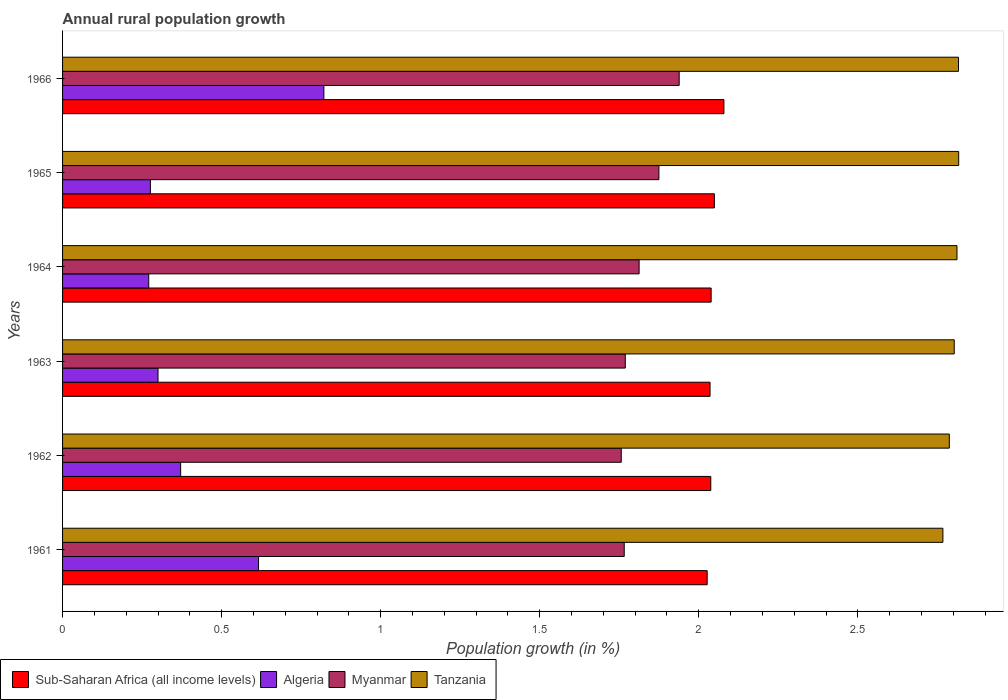How many groups of bars are there?
Your answer should be very brief. 6. How many bars are there on the 1st tick from the top?
Offer a very short reply. 4. What is the label of the 4th group of bars from the top?
Provide a succinct answer. 1963. What is the percentage of rural population growth in Myanmar in 1961?
Your answer should be compact. 1.77. Across all years, what is the maximum percentage of rural population growth in Tanzania?
Give a very brief answer. 2.82. Across all years, what is the minimum percentage of rural population growth in Sub-Saharan Africa (all income levels)?
Your answer should be compact. 2.03. In which year was the percentage of rural population growth in Myanmar maximum?
Your answer should be compact. 1966. What is the total percentage of rural population growth in Tanzania in the graph?
Your answer should be compact. 16.8. What is the difference between the percentage of rural population growth in Sub-Saharan Africa (all income levels) in 1961 and that in 1964?
Make the answer very short. -0.01. What is the difference between the percentage of rural population growth in Sub-Saharan Africa (all income levels) in 1962 and the percentage of rural population growth in Myanmar in 1963?
Your response must be concise. 0.27. What is the average percentage of rural population growth in Sub-Saharan Africa (all income levels) per year?
Offer a terse response. 2.04. In the year 1965, what is the difference between the percentage of rural population growth in Sub-Saharan Africa (all income levels) and percentage of rural population growth in Algeria?
Provide a short and direct response. 1.77. In how many years, is the percentage of rural population growth in Sub-Saharan Africa (all income levels) greater than 0.5 %?
Give a very brief answer. 6. What is the ratio of the percentage of rural population growth in Tanzania in 1962 to that in 1966?
Your answer should be compact. 0.99. Is the percentage of rural population growth in Algeria in 1963 less than that in 1964?
Ensure brevity in your answer.  No. Is the difference between the percentage of rural population growth in Sub-Saharan Africa (all income levels) in 1962 and 1964 greater than the difference between the percentage of rural population growth in Algeria in 1962 and 1964?
Your answer should be very brief. No. What is the difference between the highest and the second highest percentage of rural population growth in Sub-Saharan Africa (all income levels)?
Your response must be concise. 0.03. What is the difference between the highest and the lowest percentage of rural population growth in Sub-Saharan Africa (all income levels)?
Your response must be concise. 0.05. In how many years, is the percentage of rural population growth in Algeria greater than the average percentage of rural population growth in Algeria taken over all years?
Your answer should be compact. 2. Is the sum of the percentage of rural population growth in Myanmar in 1962 and 1966 greater than the maximum percentage of rural population growth in Tanzania across all years?
Provide a short and direct response. Yes. Is it the case that in every year, the sum of the percentage of rural population growth in Myanmar and percentage of rural population growth in Tanzania is greater than the sum of percentage of rural population growth in Sub-Saharan Africa (all income levels) and percentage of rural population growth in Algeria?
Give a very brief answer. Yes. What does the 2nd bar from the top in 1964 represents?
Keep it short and to the point. Myanmar. What does the 3rd bar from the bottom in 1964 represents?
Offer a terse response. Myanmar. How many bars are there?
Ensure brevity in your answer.  24. What is the difference between two consecutive major ticks on the X-axis?
Your answer should be very brief. 0.5. Are the values on the major ticks of X-axis written in scientific E-notation?
Your answer should be compact. No. Where does the legend appear in the graph?
Give a very brief answer. Bottom left. How are the legend labels stacked?
Offer a terse response. Horizontal. What is the title of the graph?
Provide a succinct answer. Annual rural population growth. Does "Aruba" appear as one of the legend labels in the graph?
Your answer should be compact. No. What is the label or title of the X-axis?
Your response must be concise. Population growth (in %). What is the Population growth (in %) in Sub-Saharan Africa (all income levels) in 1961?
Offer a terse response. 2.03. What is the Population growth (in %) in Algeria in 1961?
Give a very brief answer. 0.62. What is the Population growth (in %) of Myanmar in 1961?
Keep it short and to the point. 1.77. What is the Population growth (in %) of Tanzania in 1961?
Offer a terse response. 2.77. What is the Population growth (in %) in Sub-Saharan Africa (all income levels) in 1962?
Ensure brevity in your answer.  2.04. What is the Population growth (in %) in Algeria in 1962?
Your answer should be very brief. 0.37. What is the Population growth (in %) of Myanmar in 1962?
Your answer should be compact. 1.76. What is the Population growth (in %) of Tanzania in 1962?
Make the answer very short. 2.79. What is the Population growth (in %) of Sub-Saharan Africa (all income levels) in 1963?
Your answer should be compact. 2.04. What is the Population growth (in %) in Algeria in 1963?
Provide a short and direct response. 0.3. What is the Population growth (in %) of Myanmar in 1963?
Provide a succinct answer. 1.77. What is the Population growth (in %) of Tanzania in 1963?
Offer a very short reply. 2.8. What is the Population growth (in %) in Sub-Saharan Africa (all income levels) in 1964?
Give a very brief answer. 2.04. What is the Population growth (in %) in Algeria in 1964?
Your answer should be very brief. 0.27. What is the Population growth (in %) in Myanmar in 1964?
Ensure brevity in your answer.  1.81. What is the Population growth (in %) of Tanzania in 1964?
Your answer should be compact. 2.81. What is the Population growth (in %) of Sub-Saharan Africa (all income levels) in 1965?
Your answer should be very brief. 2.05. What is the Population growth (in %) in Algeria in 1965?
Provide a short and direct response. 0.28. What is the Population growth (in %) of Myanmar in 1965?
Offer a terse response. 1.87. What is the Population growth (in %) in Tanzania in 1965?
Provide a short and direct response. 2.82. What is the Population growth (in %) in Sub-Saharan Africa (all income levels) in 1966?
Ensure brevity in your answer.  2.08. What is the Population growth (in %) of Algeria in 1966?
Your answer should be compact. 0.82. What is the Population growth (in %) of Myanmar in 1966?
Offer a terse response. 1.94. What is the Population growth (in %) in Tanzania in 1966?
Your answer should be compact. 2.82. Across all years, what is the maximum Population growth (in %) in Sub-Saharan Africa (all income levels)?
Your answer should be very brief. 2.08. Across all years, what is the maximum Population growth (in %) of Algeria?
Your answer should be very brief. 0.82. Across all years, what is the maximum Population growth (in %) of Myanmar?
Your answer should be compact. 1.94. Across all years, what is the maximum Population growth (in %) in Tanzania?
Provide a succinct answer. 2.82. Across all years, what is the minimum Population growth (in %) in Sub-Saharan Africa (all income levels)?
Your answer should be compact. 2.03. Across all years, what is the minimum Population growth (in %) of Algeria?
Ensure brevity in your answer.  0.27. Across all years, what is the minimum Population growth (in %) of Myanmar?
Ensure brevity in your answer.  1.76. Across all years, what is the minimum Population growth (in %) in Tanzania?
Provide a short and direct response. 2.77. What is the total Population growth (in %) of Sub-Saharan Africa (all income levels) in the graph?
Ensure brevity in your answer.  12.27. What is the total Population growth (in %) in Algeria in the graph?
Make the answer very short. 2.66. What is the total Population growth (in %) of Myanmar in the graph?
Keep it short and to the point. 10.92. What is the total Population growth (in %) of Tanzania in the graph?
Provide a succinct answer. 16.8. What is the difference between the Population growth (in %) of Sub-Saharan Africa (all income levels) in 1961 and that in 1962?
Ensure brevity in your answer.  -0.01. What is the difference between the Population growth (in %) in Algeria in 1961 and that in 1962?
Ensure brevity in your answer.  0.24. What is the difference between the Population growth (in %) of Myanmar in 1961 and that in 1962?
Offer a very short reply. 0.01. What is the difference between the Population growth (in %) in Tanzania in 1961 and that in 1962?
Your answer should be very brief. -0.02. What is the difference between the Population growth (in %) in Sub-Saharan Africa (all income levels) in 1961 and that in 1963?
Your response must be concise. -0.01. What is the difference between the Population growth (in %) of Algeria in 1961 and that in 1963?
Provide a succinct answer. 0.32. What is the difference between the Population growth (in %) of Myanmar in 1961 and that in 1963?
Make the answer very short. -0. What is the difference between the Population growth (in %) of Tanzania in 1961 and that in 1963?
Your answer should be compact. -0.04. What is the difference between the Population growth (in %) of Sub-Saharan Africa (all income levels) in 1961 and that in 1964?
Keep it short and to the point. -0.01. What is the difference between the Population growth (in %) in Algeria in 1961 and that in 1964?
Offer a terse response. 0.35. What is the difference between the Population growth (in %) in Myanmar in 1961 and that in 1964?
Ensure brevity in your answer.  -0.05. What is the difference between the Population growth (in %) in Tanzania in 1961 and that in 1964?
Your response must be concise. -0.04. What is the difference between the Population growth (in %) of Sub-Saharan Africa (all income levels) in 1961 and that in 1965?
Ensure brevity in your answer.  -0.02. What is the difference between the Population growth (in %) of Algeria in 1961 and that in 1965?
Give a very brief answer. 0.34. What is the difference between the Population growth (in %) of Myanmar in 1961 and that in 1965?
Offer a terse response. -0.11. What is the difference between the Population growth (in %) of Tanzania in 1961 and that in 1965?
Your response must be concise. -0.05. What is the difference between the Population growth (in %) in Sub-Saharan Africa (all income levels) in 1961 and that in 1966?
Offer a very short reply. -0.05. What is the difference between the Population growth (in %) of Algeria in 1961 and that in 1966?
Your answer should be very brief. -0.21. What is the difference between the Population growth (in %) in Myanmar in 1961 and that in 1966?
Ensure brevity in your answer.  -0.17. What is the difference between the Population growth (in %) in Tanzania in 1961 and that in 1966?
Your answer should be compact. -0.05. What is the difference between the Population growth (in %) of Sub-Saharan Africa (all income levels) in 1962 and that in 1963?
Your answer should be compact. 0. What is the difference between the Population growth (in %) of Algeria in 1962 and that in 1963?
Make the answer very short. 0.07. What is the difference between the Population growth (in %) of Myanmar in 1962 and that in 1963?
Your answer should be very brief. -0.01. What is the difference between the Population growth (in %) of Tanzania in 1962 and that in 1963?
Make the answer very short. -0.02. What is the difference between the Population growth (in %) of Sub-Saharan Africa (all income levels) in 1962 and that in 1964?
Keep it short and to the point. -0. What is the difference between the Population growth (in %) of Algeria in 1962 and that in 1964?
Provide a succinct answer. 0.1. What is the difference between the Population growth (in %) in Myanmar in 1962 and that in 1964?
Keep it short and to the point. -0.06. What is the difference between the Population growth (in %) of Tanzania in 1962 and that in 1964?
Provide a succinct answer. -0.02. What is the difference between the Population growth (in %) in Sub-Saharan Africa (all income levels) in 1962 and that in 1965?
Your response must be concise. -0.01. What is the difference between the Population growth (in %) of Algeria in 1962 and that in 1965?
Provide a short and direct response. 0.1. What is the difference between the Population growth (in %) of Myanmar in 1962 and that in 1965?
Provide a short and direct response. -0.12. What is the difference between the Population growth (in %) in Tanzania in 1962 and that in 1965?
Provide a short and direct response. -0.03. What is the difference between the Population growth (in %) in Sub-Saharan Africa (all income levels) in 1962 and that in 1966?
Your answer should be very brief. -0.04. What is the difference between the Population growth (in %) in Algeria in 1962 and that in 1966?
Your response must be concise. -0.45. What is the difference between the Population growth (in %) of Myanmar in 1962 and that in 1966?
Provide a short and direct response. -0.18. What is the difference between the Population growth (in %) in Tanzania in 1962 and that in 1966?
Make the answer very short. -0.03. What is the difference between the Population growth (in %) of Sub-Saharan Africa (all income levels) in 1963 and that in 1964?
Make the answer very short. -0. What is the difference between the Population growth (in %) of Algeria in 1963 and that in 1964?
Your response must be concise. 0.03. What is the difference between the Population growth (in %) of Myanmar in 1963 and that in 1964?
Offer a terse response. -0.04. What is the difference between the Population growth (in %) in Tanzania in 1963 and that in 1964?
Keep it short and to the point. -0.01. What is the difference between the Population growth (in %) in Sub-Saharan Africa (all income levels) in 1963 and that in 1965?
Make the answer very short. -0.01. What is the difference between the Population growth (in %) of Algeria in 1963 and that in 1965?
Your answer should be very brief. 0.02. What is the difference between the Population growth (in %) of Myanmar in 1963 and that in 1965?
Your answer should be compact. -0.11. What is the difference between the Population growth (in %) in Tanzania in 1963 and that in 1965?
Make the answer very short. -0.01. What is the difference between the Population growth (in %) of Sub-Saharan Africa (all income levels) in 1963 and that in 1966?
Offer a terse response. -0.04. What is the difference between the Population growth (in %) of Algeria in 1963 and that in 1966?
Your answer should be very brief. -0.52. What is the difference between the Population growth (in %) of Myanmar in 1963 and that in 1966?
Offer a very short reply. -0.17. What is the difference between the Population growth (in %) in Tanzania in 1963 and that in 1966?
Give a very brief answer. -0.01. What is the difference between the Population growth (in %) of Sub-Saharan Africa (all income levels) in 1964 and that in 1965?
Your response must be concise. -0.01. What is the difference between the Population growth (in %) of Algeria in 1964 and that in 1965?
Provide a short and direct response. -0.01. What is the difference between the Population growth (in %) in Myanmar in 1964 and that in 1965?
Your answer should be compact. -0.06. What is the difference between the Population growth (in %) of Tanzania in 1964 and that in 1965?
Keep it short and to the point. -0.01. What is the difference between the Population growth (in %) in Sub-Saharan Africa (all income levels) in 1964 and that in 1966?
Your answer should be very brief. -0.04. What is the difference between the Population growth (in %) of Algeria in 1964 and that in 1966?
Provide a short and direct response. -0.55. What is the difference between the Population growth (in %) in Myanmar in 1964 and that in 1966?
Offer a terse response. -0.13. What is the difference between the Population growth (in %) of Tanzania in 1964 and that in 1966?
Provide a succinct answer. -0. What is the difference between the Population growth (in %) of Sub-Saharan Africa (all income levels) in 1965 and that in 1966?
Keep it short and to the point. -0.03. What is the difference between the Population growth (in %) of Algeria in 1965 and that in 1966?
Offer a terse response. -0.55. What is the difference between the Population growth (in %) of Myanmar in 1965 and that in 1966?
Make the answer very short. -0.06. What is the difference between the Population growth (in %) of Tanzania in 1965 and that in 1966?
Offer a terse response. 0. What is the difference between the Population growth (in %) of Sub-Saharan Africa (all income levels) in 1961 and the Population growth (in %) of Algeria in 1962?
Make the answer very short. 1.66. What is the difference between the Population growth (in %) of Sub-Saharan Africa (all income levels) in 1961 and the Population growth (in %) of Myanmar in 1962?
Give a very brief answer. 0.27. What is the difference between the Population growth (in %) of Sub-Saharan Africa (all income levels) in 1961 and the Population growth (in %) of Tanzania in 1962?
Provide a short and direct response. -0.76. What is the difference between the Population growth (in %) of Algeria in 1961 and the Population growth (in %) of Myanmar in 1962?
Provide a short and direct response. -1.14. What is the difference between the Population growth (in %) in Algeria in 1961 and the Population growth (in %) in Tanzania in 1962?
Offer a terse response. -2.17. What is the difference between the Population growth (in %) of Myanmar in 1961 and the Population growth (in %) of Tanzania in 1962?
Make the answer very short. -1.02. What is the difference between the Population growth (in %) of Sub-Saharan Africa (all income levels) in 1961 and the Population growth (in %) of Algeria in 1963?
Make the answer very short. 1.73. What is the difference between the Population growth (in %) in Sub-Saharan Africa (all income levels) in 1961 and the Population growth (in %) in Myanmar in 1963?
Your answer should be very brief. 0.26. What is the difference between the Population growth (in %) of Sub-Saharan Africa (all income levels) in 1961 and the Population growth (in %) of Tanzania in 1963?
Provide a succinct answer. -0.78. What is the difference between the Population growth (in %) of Algeria in 1961 and the Population growth (in %) of Myanmar in 1963?
Offer a very short reply. -1.15. What is the difference between the Population growth (in %) in Algeria in 1961 and the Population growth (in %) in Tanzania in 1963?
Your answer should be compact. -2.19. What is the difference between the Population growth (in %) in Myanmar in 1961 and the Population growth (in %) in Tanzania in 1963?
Make the answer very short. -1.04. What is the difference between the Population growth (in %) of Sub-Saharan Africa (all income levels) in 1961 and the Population growth (in %) of Algeria in 1964?
Give a very brief answer. 1.76. What is the difference between the Population growth (in %) in Sub-Saharan Africa (all income levels) in 1961 and the Population growth (in %) in Myanmar in 1964?
Your answer should be compact. 0.21. What is the difference between the Population growth (in %) of Sub-Saharan Africa (all income levels) in 1961 and the Population growth (in %) of Tanzania in 1964?
Give a very brief answer. -0.79. What is the difference between the Population growth (in %) in Algeria in 1961 and the Population growth (in %) in Myanmar in 1964?
Keep it short and to the point. -1.2. What is the difference between the Population growth (in %) of Algeria in 1961 and the Population growth (in %) of Tanzania in 1964?
Your answer should be compact. -2.2. What is the difference between the Population growth (in %) of Myanmar in 1961 and the Population growth (in %) of Tanzania in 1964?
Your answer should be compact. -1.05. What is the difference between the Population growth (in %) in Sub-Saharan Africa (all income levels) in 1961 and the Population growth (in %) in Algeria in 1965?
Offer a very short reply. 1.75. What is the difference between the Population growth (in %) of Sub-Saharan Africa (all income levels) in 1961 and the Population growth (in %) of Myanmar in 1965?
Provide a succinct answer. 0.15. What is the difference between the Population growth (in %) in Sub-Saharan Africa (all income levels) in 1961 and the Population growth (in %) in Tanzania in 1965?
Keep it short and to the point. -0.79. What is the difference between the Population growth (in %) of Algeria in 1961 and the Population growth (in %) of Myanmar in 1965?
Ensure brevity in your answer.  -1.26. What is the difference between the Population growth (in %) of Algeria in 1961 and the Population growth (in %) of Tanzania in 1965?
Offer a very short reply. -2.2. What is the difference between the Population growth (in %) in Myanmar in 1961 and the Population growth (in %) in Tanzania in 1965?
Make the answer very short. -1.05. What is the difference between the Population growth (in %) in Sub-Saharan Africa (all income levels) in 1961 and the Population growth (in %) in Algeria in 1966?
Keep it short and to the point. 1.2. What is the difference between the Population growth (in %) in Sub-Saharan Africa (all income levels) in 1961 and the Population growth (in %) in Myanmar in 1966?
Make the answer very short. 0.09. What is the difference between the Population growth (in %) in Sub-Saharan Africa (all income levels) in 1961 and the Population growth (in %) in Tanzania in 1966?
Ensure brevity in your answer.  -0.79. What is the difference between the Population growth (in %) in Algeria in 1961 and the Population growth (in %) in Myanmar in 1966?
Keep it short and to the point. -1.32. What is the difference between the Population growth (in %) in Algeria in 1961 and the Population growth (in %) in Tanzania in 1966?
Offer a terse response. -2.2. What is the difference between the Population growth (in %) in Myanmar in 1961 and the Population growth (in %) in Tanzania in 1966?
Offer a very short reply. -1.05. What is the difference between the Population growth (in %) in Sub-Saharan Africa (all income levels) in 1962 and the Population growth (in %) in Algeria in 1963?
Your answer should be very brief. 1.74. What is the difference between the Population growth (in %) of Sub-Saharan Africa (all income levels) in 1962 and the Population growth (in %) of Myanmar in 1963?
Ensure brevity in your answer.  0.27. What is the difference between the Population growth (in %) of Sub-Saharan Africa (all income levels) in 1962 and the Population growth (in %) of Tanzania in 1963?
Provide a short and direct response. -0.77. What is the difference between the Population growth (in %) of Algeria in 1962 and the Population growth (in %) of Myanmar in 1963?
Keep it short and to the point. -1.4. What is the difference between the Population growth (in %) in Algeria in 1962 and the Population growth (in %) in Tanzania in 1963?
Provide a short and direct response. -2.43. What is the difference between the Population growth (in %) in Myanmar in 1962 and the Population growth (in %) in Tanzania in 1963?
Your answer should be very brief. -1.05. What is the difference between the Population growth (in %) in Sub-Saharan Africa (all income levels) in 1962 and the Population growth (in %) in Algeria in 1964?
Your response must be concise. 1.77. What is the difference between the Population growth (in %) in Sub-Saharan Africa (all income levels) in 1962 and the Population growth (in %) in Myanmar in 1964?
Keep it short and to the point. 0.23. What is the difference between the Population growth (in %) in Sub-Saharan Africa (all income levels) in 1962 and the Population growth (in %) in Tanzania in 1964?
Keep it short and to the point. -0.77. What is the difference between the Population growth (in %) in Algeria in 1962 and the Population growth (in %) in Myanmar in 1964?
Your answer should be compact. -1.44. What is the difference between the Population growth (in %) in Algeria in 1962 and the Population growth (in %) in Tanzania in 1964?
Offer a terse response. -2.44. What is the difference between the Population growth (in %) in Myanmar in 1962 and the Population growth (in %) in Tanzania in 1964?
Your answer should be compact. -1.06. What is the difference between the Population growth (in %) in Sub-Saharan Africa (all income levels) in 1962 and the Population growth (in %) in Algeria in 1965?
Your answer should be very brief. 1.76. What is the difference between the Population growth (in %) of Sub-Saharan Africa (all income levels) in 1962 and the Population growth (in %) of Myanmar in 1965?
Provide a succinct answer. 0.16. What is the difference between the Population growth (in %) of Sub-Saharan Africa (all income levels) in 1962 and the Population growth (in %) of Tanzania in 1965?
Your answer should be compact. -0.78. What is the difference between the Population growth (in %) of Algeria in 1962 and the Population growth (in %) of Myanmar in 1965?
Make the answer very short. -1.5. What is the difference between the Population growth (in %) of Algeria in 1962 and the Population growth (in %) of Tanzania in 1965?
Your answer should be compact. -2.45. What is the difference between the Population growth (in %) in Myanmar in 1962 and the Population growth (in %) in Tanzania in 1965?
Ensure brevity in your answer.  -1.06. What is the difference between the Population growth (in %) of Sub-Saharan Africa (all income levels) in 1962 and the Population growth (in %) of Algeria in 1966?
Provide a succinct answer. 1.22. What is the difference between the Population growth (in %) of Sub-Saharan Africa (all income levels) in 1962 and the Population growth (in %) of Myanmar in 1966?
Your answer should be very brief. 0.1. What is the difference between the Population growth (in %) in Sub-Saharan Africa (all income levels) in 1962 and the Population growth (in %) in Tanzania in 1966?
Ensure brevity in your answer.  -0.78. What is the difference between the Population growth (in %) of Algeria in 1962 and the Population growth (in %) of Myanmar in 1966?
Give a very brief answer. -1.57. What is the difference between the Population growth (in %) in Algeria in 1962 and the Population growth (in %) in Tanzania in 1966?
Give a very brief answer. -2.45. What is the difference between the Population growth (in %) in Myanmar in 1962 and the Population growth (in %) in Tanzania in 1966?
Your answer should be very brief. -1.06. What is the difference between the Population growth (in %) in Sub-Saharan Africa (all income levels) in 1963 and the Population growth (in %) in Algeria in 1964?
Your response must be concise. 1.76. What is the difference between the Population growth (in %) in Sub-Saharan Africa (all income levels) in 1963 and the Population growth (in %) in Myanmar in 1964?
Provide a short and direct response. 0.22. What is the difference between the Population growth (in %) of Sub-Saharan Africa (all income levels) in 1963 and the Population growth (in %) of Tanzania in 1964?
Your answer should be compact. -0.78. What is the difference between the Population growth (in %) of Algeria in 1963 and the Population growth (in %) of Myanmar in 1964?
Give a very brief answer. -1.51. What is the difference between the Population growth (in %) of Algeria in 1963 and the Population growth (in %) of Tanzania in 1964?
Provide a succinct answer. -2.51. What is the difference between the Population growth (in %) of Myanmar in 1963 and the Population growth (in %) of Tanzania in 1964?
Keep it short and to the point. -1.04. What is the difference between the Population growth (in %) in Sub-Saharan Africa (all income levels) in 1963 and the Population growth (in %) in Algeria in 1965?
Provide a succinct answer. 1.76. What is the difference between the Population growth (in %) of Sub-Saharan Africa (all income levels) in 1963 and the Population growth (in %) of Myanmar in 1965?
Keep it short and to the point. 0.16. What is the difference between the Population growth (in %) in Sub-Saharan Africa (all income levels) in 1963 and the Population growth (in %) in Tanzania in 1965?
Keep it short and to the point. -0.78. What is the difference between the Population growth (in %) in Algeria in 1963 and the Population growth (in %) in Myanmar in 1965?
Make the answer very short. -1.57. What is the difference between the Population growth (in %) in Algeria in 1963 and the Population growth (in %) in Tanzania in 1965?
Offer a very short reply. -2.52. What is the difference between the Population growth (in %) in Myanmar in 1963 and the Population growth (in %) in Tanzania in 1965?
Provide a short and direct response. -1.05. What is the difference between the Population growth (in %) of Sub-Saharan Africa (all income levels) in 1963 and the Population growth (in %) of Algeria in 1966?
Offer a terse response. 1.21. What is the difference between the Population growth (in %) in Sub-Saharan Africa (all income levels) in 1963 and the Population growth (in %) in Myanmar in 1966?
Your response must be concise. 0.1. What is the difference between the Population growth (in %) in Sub-Saharan Africa (all income levels) in 1963 and the Population growth (in %) in Tanzania in 1966?
Your answer should be compact. -0.78. What is the difference between the Population growth (in %) of Algeria in 1963 and the Population growth (in %) of Myanmar in 1966?
Your answer should be very brief. -1.64. What is the difference between the Population growth (in %) in Algeria in 1963 and the Population growth (in %) in Tanzania in 1966?
Provide a short and direct response. -2.52. What is the difference between the Population growth (in %) in Myanmar in 1963 and the Population growth (in %) in Tanzania in 1966?
Provide a succinct answer. -1.05. What is the difference between the Population growth (in %) of Sub-Saharan Africa (all income levels) in 1964 and the Population growth (in %) of Algeria in 1965?
Give a very brief answer. 1.76. What is the difference between the Population growth (in %) of Sub-Saharan Africa (all income levels) in 1964 and the Population growth (in %) of Myanmar in 1965?
Your answer should be compact. 0.16. What is the difference between the Population growth (in %) of Sub-Saharan Africa (all income levels) in 1964 and the Population growth (in %) of Tanzania in 1965?
Your answer should be very brief. -0.78. What is the difference between the Population growth (in %) of Algeria in 1964 and the Population growth (in %) of Myanmar in 1965?
Your answer should be very brief. -1.6. What is the difference between the Population growth (in %) of Algeria in 1964 and the Population growth (in %) of Tanzania in 1965?
Ensure brevity in your answer.  -2.55. What is the difference between the Population growth (in %) of Myanmar in 1964 and the Population growth (in %) of Tanzania in 1965?
Your answer should be compact. -1. What is the difference between the Population growth (in %) of Sub-Saharan Africa (all income levels) in 1964 and the Population growth (in %) of Algeria in 1966?
Keep it short and to the point. 1.22. What is the difference between the Population growth (in %) in Sub-Saharan Africa (all income levels) in 1964 and the Population growth (in %) in Myanmar in 1966?
Make the answer very short. 0.1. What is the difference between the Population growth (in %) of Sub-Saharan Africa (all income levels) in 1964 and the Population growth (in %) of Tanzania in 1966?
Your response must be concise. -0.78. What is the difference between the Population growth (in %) of Algeria in 1964 and the Population growth (in %) of Myanmar in 1966?
Keep it short and to the point. -1.67. What is the difference between the Population growth (in %) of Algeria in 1964 and the Population growth (in %) of Tanzania in 1966?
Offer a terse response. -2.55. What is the difference between the Population growth (in %) in Myanmar in 1964 and the Population growth (in %) in Tanzania in 1966?
Ensure brevity in your answer.  -1. What is the difference between the Population growth (in %) of Sub-Saharan Africa (all income levels) in 1965 and the Population growth (in %) of Algeria in 1966?
Keep it short and to the point. 1.23. What is the difference between the Population growth (in %) of Sub-Saharan Africa (all income levels) in 1965 and the Population growth (in %) of Myanmar in 1966?
Offer a very short reply. 0.11. What is the difference between the Population growth (in %) of Sub-Saharan Africa (all income levels) in 1965 and the Population growth (in %) of Tanzania in 1966?
Make the answer very short. -0.77. What is the difference between the Population growth (in %) in Algeria in 1965 and the Population growth (in %) in Myanmar in 1966?
Your response must be concise. -1.66. What is the difference between the Population growth (in %) in Algeria in 1965 and the Population growth (in %) in Tanzania in 1966?
Your answer should be compact. -2.54. What is the difference between the Population growth (in %) in Myanmar in 1965 and the Population growth (in %) in Tanzania in 1966?
Give a very brief answer. -0.94. What is the average Population growth (in %) of Sub-Saharan Africa (all income levels) per year?
Keep it short and to the point. 2.04. What is the average Population growth (in %) in Algeria per year?
Make the answer very short. 0.44. What is the average Population growth (in %) of Myanmar per year?
Provide a succinct answer. 1.82. What is the average Population growth (in %) of Tanzania per year?
Offer a terse response. 2.8. In the year 1961, what is the difference between the Population growth (in %) of Sub-Saharan Africa (all income levels) and Population growth (in %) of Algeria?
Provide a succinct answer. 1.41. In the year 1961, what is the difference between the Population growth (in %) in Sub-Saharan Africa (all income levels) and Population growth (in %) in Myanmar?
Make the answer very short. 0.26. In the year 1961, what is the difference between the Population growth (in %) of Sub-Saharan Africa (all income levels) and Population growth (in %) of Tanzania?
Make the answer very short. -0.74. In the year 1961, what is the difference between the Population growth (in %) in Algeria and Population growth (in %) in Myanmar?
Give a very brief answer. -1.15. In the year 1961, what is the difference between the Population growth (in %) of Algeria and Population growth (in %) of Tanzania?
Ensure brevity in your answer.  -2.15. In the year 1961, what is the difference between the Population growth (in %) in Myanmar and Population growth (in %) in Tanzania?
Make the answer very short. -1. In the year 1962, what is the difference between the Population growth (in %) of Sub-Saharan Africa (all income levels) and Population growth (in %) of Algeria?
Make the answer very short. 1.67. In the year 1962, what is the difference between the Population growth (in %) of Sub-Saharan Africa (all income levels) and Population growth (in %) of Myanmar?
Your answer should be compact. 0.28. In the year 1962, what is the difference between the Population growth (in %) of Sub-Saharan Africa (all income levels) and Population growth (in %) of Tanzania?
Keep it short and to the point. -0.75. In the year 1962, what is the difference between the Population growth (in %) of Algeria and Population growth (in %) of Myanmar?
Provide a succinct answer. -1.39. In the year 1962, what is the difference between the Population growth (in %) in Algeria and Population growth (in %) in Tanzania?
Provide a succinct answer. -2.42. In the year 1962, what is the difference between the Population growth (in %) of Myanmar and Population growth (in %) of Tanzania?
Make the answer very short. -1.03. In the year 1963, what is the difference between the Population growth (in %) in Sub-Saharan Africa (all income levels) and Population growth (in %) in Algeria?
Keep it short and to the point. 1.74. In the year 1963, what is the difference between the Population growth (in %) in Sub-Saharan Africa (all income levels) and Population growth (in %) in Myanmar?
Make the answer very short. 0.27. In the year 1963, what is the difference between the Population growth (in %) of Sub-Saharan Africa (all income levels) and Population growth (in %) of Tanzania?
Provide a succinct answer. -0.77. In the year 1963, what is the difference between the Population growth (in %) in Algeria and Population growth (in %) in Myanmar?
Offer a very short reply. -1.47. In the year 1963, what is the difference between the Population growth (in %) of Algeria and Population growth (in %) of Tanzania?
Make the answer very short. -2.5. In the year 1963, what is the difference between the Population growth (in %) in Myanmar and Population growth (in %) in Tanzania?
Offer a terse response. -1.03. In the year 1964, what is the difference between the Population growth (in %) in Sub-Saharan Africa (all income levels) and Population growth (in %) in Algeria?
Offer a very short reply. 1.77. In the year 1964, what is the difference between the Population growth (in %) of Sub-Saharan Africa (all income levels) and Population growth (in %) of Myanmar?
Your answer should be compact. 0.23. In the year 1964, what is the difference between the Population growth (in %) of Sub-Saharan Africa (all income levels) and Population growth (in %) of Tanzania?
Your answer should be very brief. -0.77. In the year 1964, what is the difference between the Population growth (in %) of Algeria and Population growth (in %) of Myanmar?
Make the answer very short. -1.54. In the year 1964, what is the difference between the Population growth (in %) in Algeria and Population growth (in %) in Tanzania?
Provide a short and direct response. -2.54. In the year 1964, what is the difference between the Population growth (in %) in Myanmar and Population growth (in %) in Tanzania?
Ensure brevity in your answer.  -1. In the year 1965, what is the difference between the Population growth (in %) in Sub-Saharan Africa (all income levels) and Population growth (in %) in Algeria?
Make the answer very short. 1.77. In the year 1965, what is the difference between the Population growth (in %) of Sub-Saharan Africa (all income levels) and Population growth (in %) of Myanmar?
Ensure brevity in your answer.  0.17. In the year 1965, what is the difference between the Population growth (in %) in Sub-Saharan Africa (all income levels) and Population growth (in %) in Tanzania?
Give a very brief answer. -0.77. In the year 1965, what is the difference between the Population growth (in %) in Algeria and Population growth (in %) in Myanmar?
Keep it short and to the point. -1.6. In the year 1965, what is the difference between the Population growth (in %) of Algeria and Population growth (in %) of Tanzania?
Your response must be concise. -2.54. In the year 1965, what is the difference between the Population growth (in %) of Myanmar and Population growth (in %) of Tanzania?
Provide a succinct answer. -0.94. In the year 1966, what is the difference between the Population growth (in %) in Sub-Saharan Africa (all income levels) and Population growth (in %) in Algeria?
Your answer should be compact. 1.26. In the year 1966, what is the difference between the Population growth (in %) of Sub-Saharan Africa (all income levels) and Population growth (in %) of Myanmar?
Make the answer very short. 0.14. In the year 1966, what is the difference between the Population growth (in %) of Sub-Saharan Africa (all income levels) and Population growth (in %) of Tanzania?
Provide a succinct answer. -0.74. In the year 1966, what is the difference between the Population growth (in %) of Algeria and Population growth (in %) of Myanmar?
Make the answer very short. -1.12. In the year 1966, what is the difference between the Population growth (in %) of Algeria and Population growth (in %) of Tanzania?
Keep it short and to the point. -1.99. In the year 1966, what is the difference between the Population growth (in %) in Myanmar and Population growth (in %) in Tanzania?
Ensure brevity in your answer.  -0.88. What is the ratio of the Population growth (in %) of Sub-Saharan Africa (all income levels) in 1961 to that in 1962?
Offer a terse response. 0.99. What is the ratio of the Population growth (in %) in Algeria in 1961 to that in 1962?
Give a very brief answer. 1.66. What is the ratio of the Population growth (in %) of Myanmar in 1961 to that in 1962?
Your answer should be compact. 1.01. What is the ratio of the Population growth (in %) of Algeria in 1961 to that in 1963?
Offer a terse response. 2.05. What is the ratio of the Population growth (in %) of Myanmar in 1961 to that in 1963?
Offer a terse response. 1. What is the ratio of the Population growth (in %) in Tanzania in 1961 to that in 1963?
Make the answer very short. 0.99. What is the ratio of the Population growth (in %) of Sub-Saharan Africa (all income levels) in 1961 to that in 1964?
Offer a terse response. 0.99. What is the ratio of the Population growth (in %) in Algeria in 1961 to that in 1964?
Keep it short and to the point. 2.27. What is the ratio of the Population growth (in %) in Myanmar in 1961 to that in 1964?
Keep it short and to the point. 0.97. What is the ratio of the Population growth (in %) of Tanzania in 1961 to that in 1964?
Provide a succinct answer. 0.98. What is the ratio of the Population growth (in %) in Sub-Saharan Africa (all income levels) in 1961 to that in 1965?
Provide a succinct answer. 0.99. What is the ratio of the Population growth (in %) of Algeria in 1961 to that in 1965?
Keep it short and to the point. 2.23. What is the ratio of the Population growth (in %) in Myanmar in 1961 to that in 1965?
Keep it short and to the point. 0.94. What is the ratio of the Population growth (in %) of Tanzania in 1961 to that in 1965?
Your answer should be very brief. 0.98. What is the ratio of the Population growth (in %) of Sub-Saharan Africa (all income levels) in 1961 to that in 1966?
Ensure brevity in your answer.  0.97. What is the ratio of the Population growth (in %) in Algeria in 1961 to that in 1966?
Your answer should be very brief. 0.75. What is the ratio of the Population growth (in %) of Myanmar in 1961 to that in 1966?
Your answer should be compact. 0.91. What is the ratio of the Population growth (in %) of Tanzania in 1961 to that in 1966?
Offer a very short reply. 0.98. What is the ratio of the Population growth (in %) of Sub-Saharan Africa (all income levels) in 1962 to that in 1963?
Ensure brevity in your answer.  1. What is the ratio of the Population growth (in %) in Algeria in 1962 to that in 1963?
Ensure brevity in your answer.  1.24. What is the ratio of the Population growth (in %) in Myanmar in 1962 to that in 1963?
Make the answer very short. 0.99. What is the ratio of the Population growth (in %) in Tanzania in 1962 to that in 1963?
Give a very brief answer. 0.99. What is the ratio of the Population growth (in %) in Sub-Saharan Africa (all income levels) in 1962 to that in 1964?
Offer a very short reply. 1. What is the ratio of the Population growth (in %) in Algeria in 1962 to that in 1964?
Offer a very short reply. 1.37. What is the ratio of the Population growth (in %) in Myanmar in 1962 to that in 1964?
Offer a terse response. 0.97. What is the ratio of the Population growth (in %) in Algeria in 1962 to that in 1965?
Offer a terse response. 1.34. What is the ratio of the Population growth (in %) of Myanmar in 1962 to that in 1965?
Ensure brevity in your answer.  0.94. What is the ratio of the Population growth (in %) of Sub-Saharan Africa (all income levels) in 1962 to that in 1966?
Ensure brevity in your answer.  0.98. What is the ratio of the Population growth (in %) in Algeria in 1962 to that in 1966?
Ensure brevity in your answer.  0.45. What is the ratio of the Population growth (in %) in Myanmar in 1962 to that in 1966?
Your answer should be compact. 0.91. What is the ratio of the Population growth (in %) in Sub-Saharan Africa (all income levels) in 1963 to that in 1964?
Your answer should be compact. 1. What is the ratio of the Population growth (in %) of Algeria in 1963 to that in 1964?
Provide a short and direct response. 1.11. What is the ratio of the Population growth (in %) of Algeria in 1963 to that in 1965?
Keep it short and to the point. 1.09. What is the ratio of the Population growth (in %) in Myanmar in 1963 to that in 1965?
Make the answer very short. 0.94. What is the ratio of the Population growth (in %) of Sub-Saharan Africa (all income levels) in 1963 to that in 1966?
Ensure brevity in your answer.  0.98. What is the ratio of the Population growth (in %) of Algeria in 1963 to that in 1966?
Keep it short and to the point. 0.37. What is the ratio of the Population growth (in %) of Myanmar in 1963 to that in 1966?
Provide a succinct answer. 0.91. What is the ratio of the Population growth (in %) of Tanzania in 1963 to that in 1966?
Give a very brief answer. 1. What is the ratio of the Population growth (in %) of Sub-Saharan Africa (all income levels) in 1964 to that in 1965?
Provide a short and direct response. 0.99. What is the ratio of the Population growth (in %) of Algeria in 1964 to that in 1965?
Provide a succinct answer. 0.98. What is the ratio of the Population growth (in %) in Myanmar in 1964 to that in 1965?
Provide a short and direct response. 0.97. What is the ratio of the Population growth (in %) in Sub-Saharan Africa (all income levels) in 1964 to that in 1966?
Provide a succinct answer. 0.98. What is the ratio of the Population growth (in %) in Algeria in 1964 to that in 1966?
Your response must be concise. 0.33. What is the ratio of the Population growth (in %) of Myanmar in 1964 to that in 1966?
Offer a very short reply. 0.94. What is the ratio of the Population growth (in %) in Tanzania in 1964 to that in 1966?
Keep it short and to the point. 1. What is the ratio of the Population growth (in %) in Sub-Saharan Africa (all income levels) in 1965 to that in 1966?
Give a very brief answer. 0.99. What is the ratio of the Population growth (in %) in Algeria in 1965 to that in 1966?
Your answer should be very brief. 0.34. What is the ratio of the Population growth (in %) of Myanmar in 1965 to that in 1966?
Provide a short and direct response. 0.97. What is the ratio of the Population growth (in %) of Tanzania in 1965 to that in 1966?
Offer a very short reply. 1. What is the difference between the highest and the second highest Population growth (in %) in Sub-Saharan Africa (all income levels)?
Your answer should be compact. 0.03. What is the difference between the highest and the second highest Population growth (in %) in Algeria?
Keep it short and to the point. 0.21. What is the difference between the highest and the second highest Population growth (in %) of Myanmar?
Offer a terse response. 0.06. What is the difference between the highest and the second highest Population growth (in %) in Tanzania?
Give a very brief answer. 0. What is the difference between the highest and the lowest Population growth (in %) of Sub-Saharan Africa (all income levels)?
Your answer should be compact. 0.05. What is the difference between the highest and the lowest Population growth (in %) in Algeria?
Ensure brevity in your answer.  0.55. What is the difference between the highest and the lowest Population growth (in %) in Myanmar?
Make the answer very short. 0.18. What is the difference between the highest and the lowest Population growth (in %) in Tanzania?
Give a very brief answer. 0.05. 